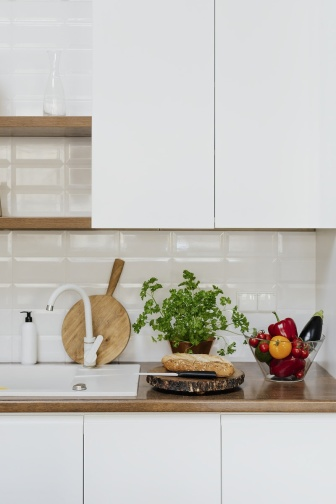What elements make this kitchen modern? Several elements contribute to the modern design of this kitchen. The monochromatic color scheme, with white cabinets and tiles, provides a clean and streamlined look. The contemporary black faucet adds a touch of sophistication, while the sleek wooden countertop offers a natural yet stylish contrast. Additionally, the minimalistic and functional arrangement of objects, combined with the use of natural textures such as wood and stone, encapsulates modern design principles. What creative uses can you imagine for this space beyond cooking? Beyond cooking, this kitchen could be a wonderful space for small gatherings or casual socializing with friends. The countertop can serve as a makeshift bar for mixing drinks or an impromptu serving area for finger foods during a cozy get-together. Additionally, it could be utilized as a workspace for crafting or hobby projects, given its clean and open layout. The tranquil vibe of the kitchen makes it an ideal spot for reading a book or enjoying a cup of coffee while taking in the serene surroundings. Can you imagine a magical event happening in this kitchen, like in a fantasy movie? Imagine the kitchen bathed in the glow of twilight, with an ethereal ambiance. Suddenly, the potted herb plant begins to glow and hum with a soft, magical energy. The fruits in the bowl start to levitate and swirl in a graceful dance above the countertop. The marble pestle and mortar move on their own, mixing ingredients to create an enchanted potion. The tiles on the backsplash shimmer, revealing hidden runes that tell an ancient culinary secret. This enchanted kitchen, with its magical elements, becomes a hub of mystical culinary adventures, where every meal prepared is infused with enchantment and wonder. 